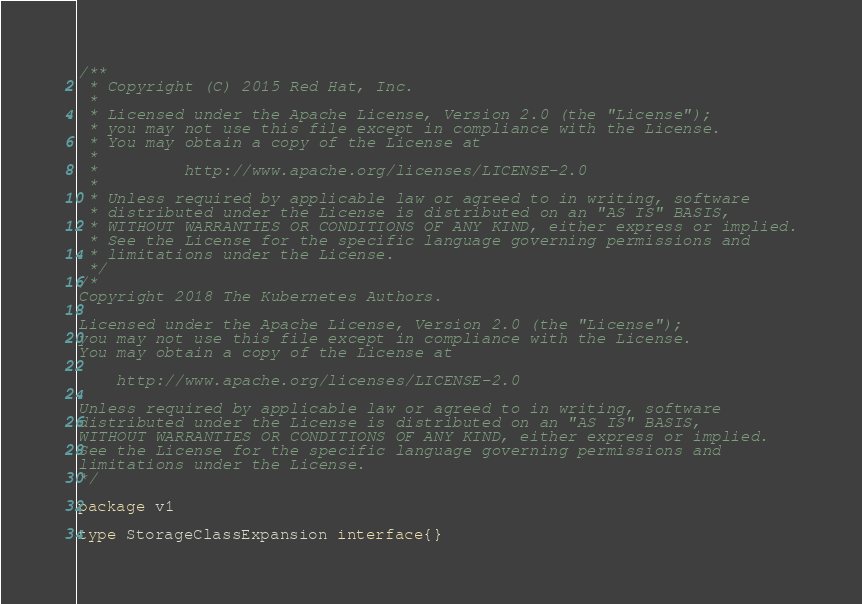Convert code to text. <code><loc_0><loc_0><loc_500><loc_500><_Go_>/**
 * Copyright (C) 2015 Red Hat, Inc.
 *
 * Licensed under the Apache License, Version 2.0 (the "License");
 * you may not use this file except in compliance with the License.
 * You may obtain a copy of the License at
 *
 *         http://www.apache.org/licenses/LICENSE-2.0
 *
 * Unless required by applicable law or agreed to in writing, software
 * distributed under the License is distributed on an "AS IS" BASIS,
 * WITHOUT WARRANTIES OR CONDITIONS OF ANY KIND, either express or implied.
 * See the License for the specific language governing permissions and
 * limitations under the License.
 */
/*
Copyright 2018 The Kubernetes Authors.

Licensed under the Apache License, Version 2.0 (the "License");
you may not use this file except in compliance with the License.
You may obtain a copy of the License at

    http://www.apache.org/licenses/LICENSE-2.0

Unless required by applicable law or agreed to in writing, software
distributed under the License is distributed on an "AS IS" BASIS,
WITHOUT WARRANTIES OR CONDITIONS OF ANY KIND, either express or implied.
See the License for the specific language governing permissions and
limitations under the License.
*/

package v1

type StorageClassExpansion interface{}
</code> 